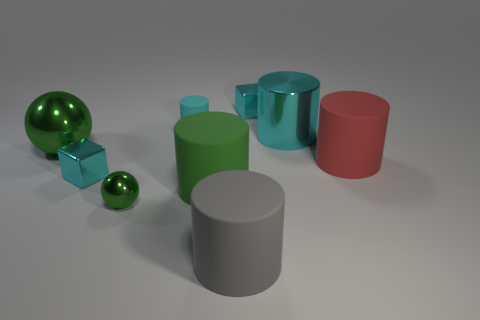There is a cylinder that is the same color as the small ball; what is it made of?
Offer a terse response. Rubber. What number of objects are green objects or gray rubber objects?
Provide a succinct answer. 4. Are the small cube that is right of the tiny green object and the large red cylinder made of the same material?
Ensure brevity in your answer.  No. What number of things are big matte things on the right side of the large cyan cylinder or yellow rubber cylinders?
Your answer should be compact. 1. What color is the small cylinder that is the same material as the gray object?
Provide a short and direct response. Cyan. Are there any gray objects of the same size as the gray cylinder?
Provide a short and direct response. No. Is the color of the tiny shiny object to the right of the green cylinder the same as the big shiny cylinder?
Your answer should be very brief. Yes. What color is the thing that is right of the cyan rubber cylinder and behind the big cyan shiny cylinder?
Your answer should be very brief. Cyan. There is a green metallic thing that is the same size as the gray thing; what is its shape?
Your response must be concise. Sphere. Are there any large cyan metal things of the same shape as the big green rubber thing?
Keep it short and to the point. Yes. 